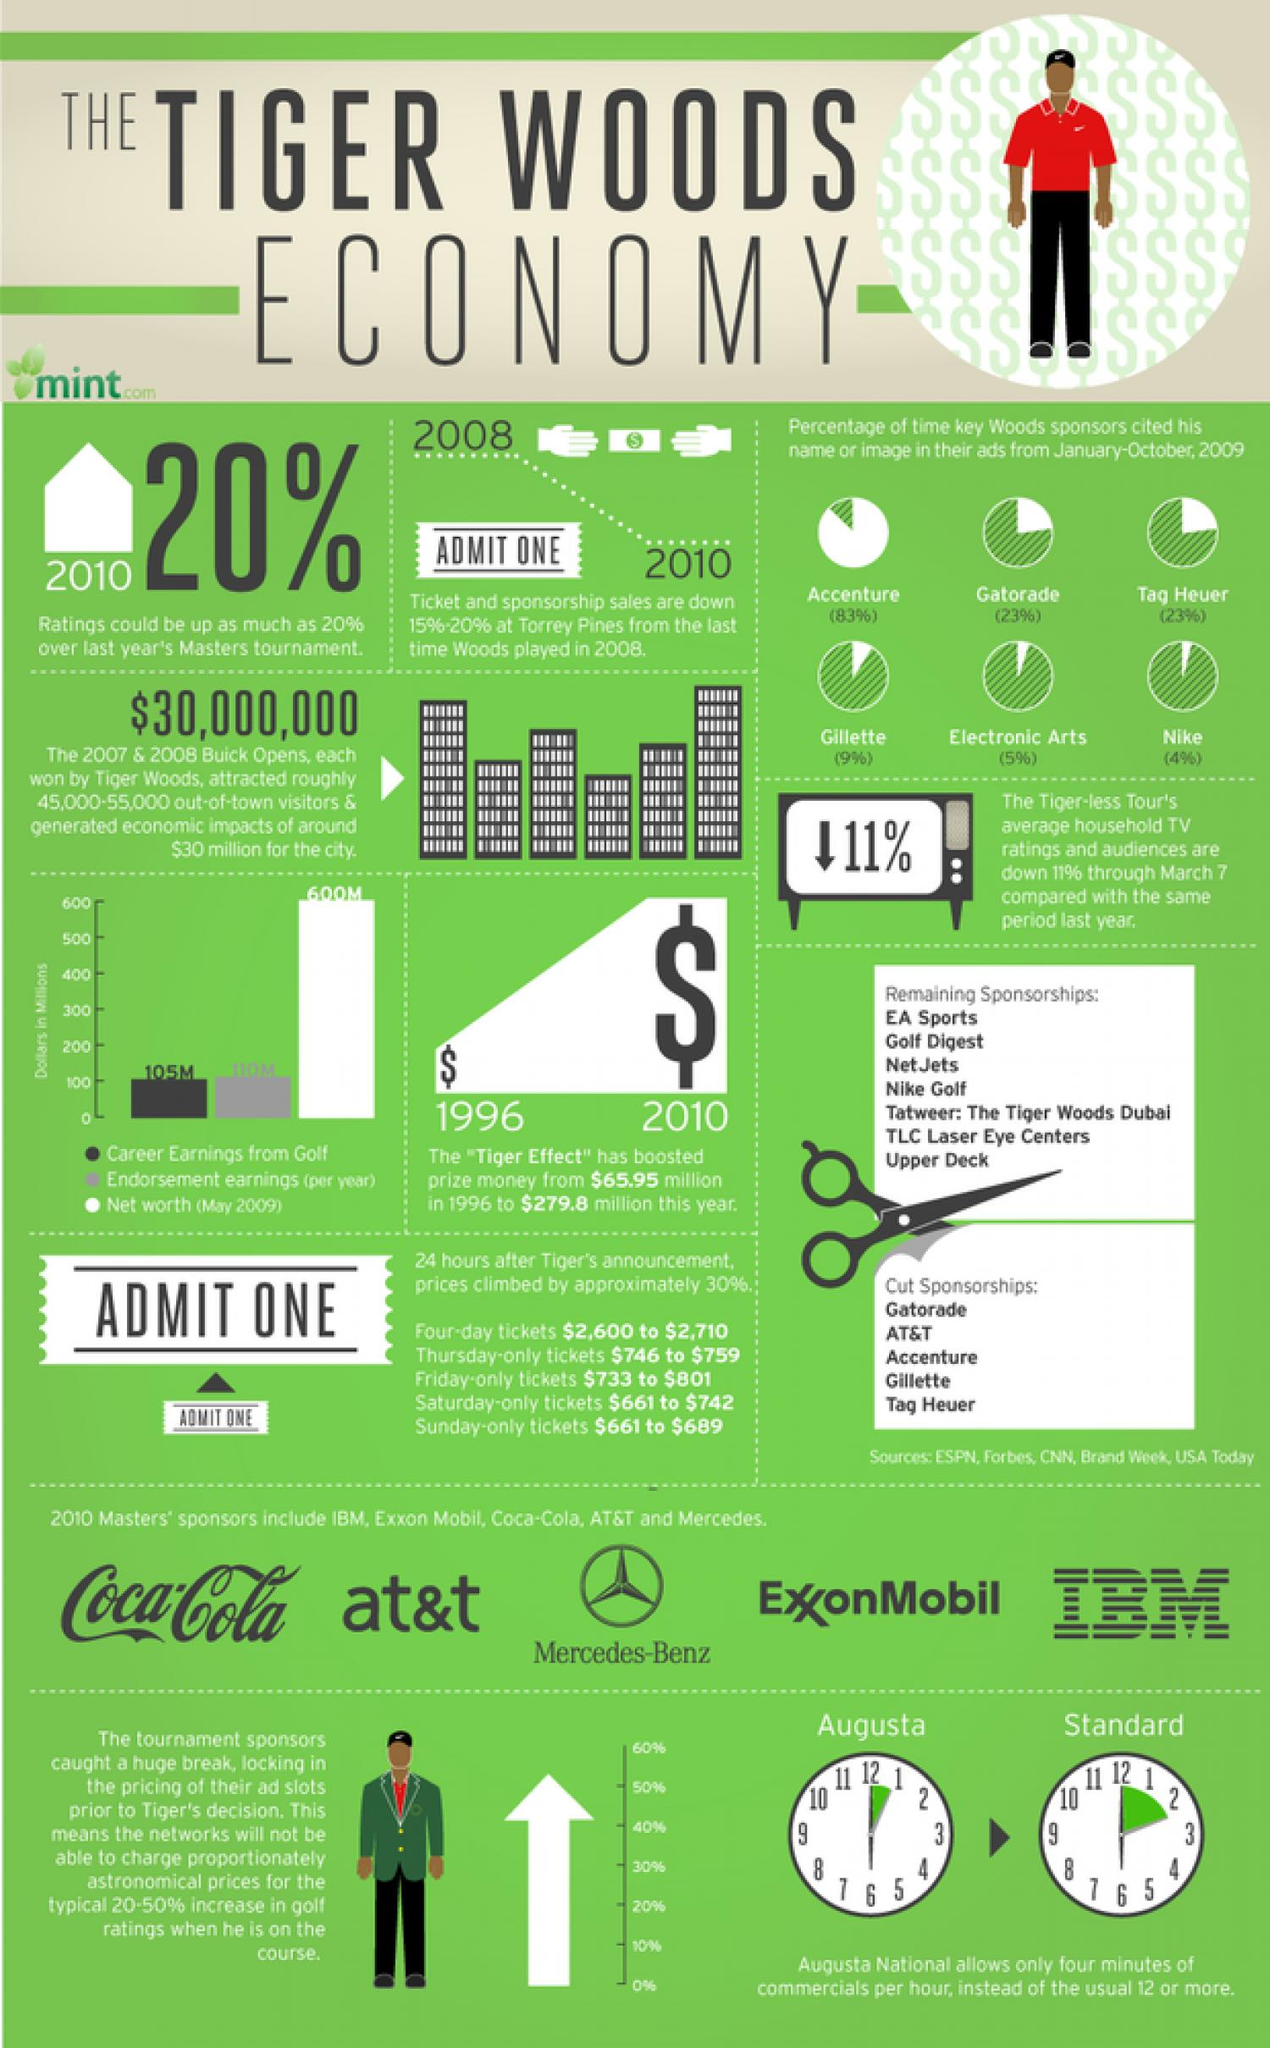Indicate a few pertinent items in this graphic. Seven remaining sponsorships remain unaccounted for. Five master sponsors have been identified. Five cut sponsorships have been identified. 